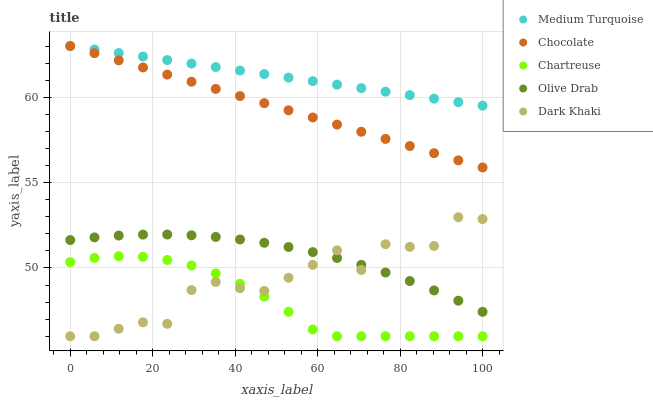Does Chartreuse have the minimum area under the curve?
Answer yes or no. Yes. Does Medium Turquoise have the maximum area under the curve?
Answer yes or no. Yes. Does Olive Drab have the minimum area under the curve?
Answer yes or no. No. Does Olive Drab have the maximum area under the curve?
Answer yes or no. No. Is Chocolate the smoothest?
Answer yes or no. Yes. Is Dark Khaki the roughest?
Answer yes or no. Yes. Is Chartreuse the smoothest?
Answer yes or no. No. Is Chartreuse the roughest?
Answer yes or no. No. Does Dark Khaki have the lowest value?
Answer yes or no. Yes. Does Olive Drab have the lowest value?
Answer yes or no. No. Does Chocolate have the highest value?
Answer yes or no. Yes. Does Olive Drab have the highest value?
Answer yes or no. No. Is Chartreuse less than Medium Turquoise?
Answer yes or no. Yes. Is Chocolate greater than Chartreuse?
Answer yes or no. Yes. Does Chartreuse intersect Dark Khaki?
Answer yes or no. Yes. Is Chartreuse less than Dark Khaki?
Answer yes or no. No. Is Chartreuse greater than Dark Khaki?
Answer yes or no. No. Does Chartreuse intersect Medium Turquoise?
Answer yes or no. No. 